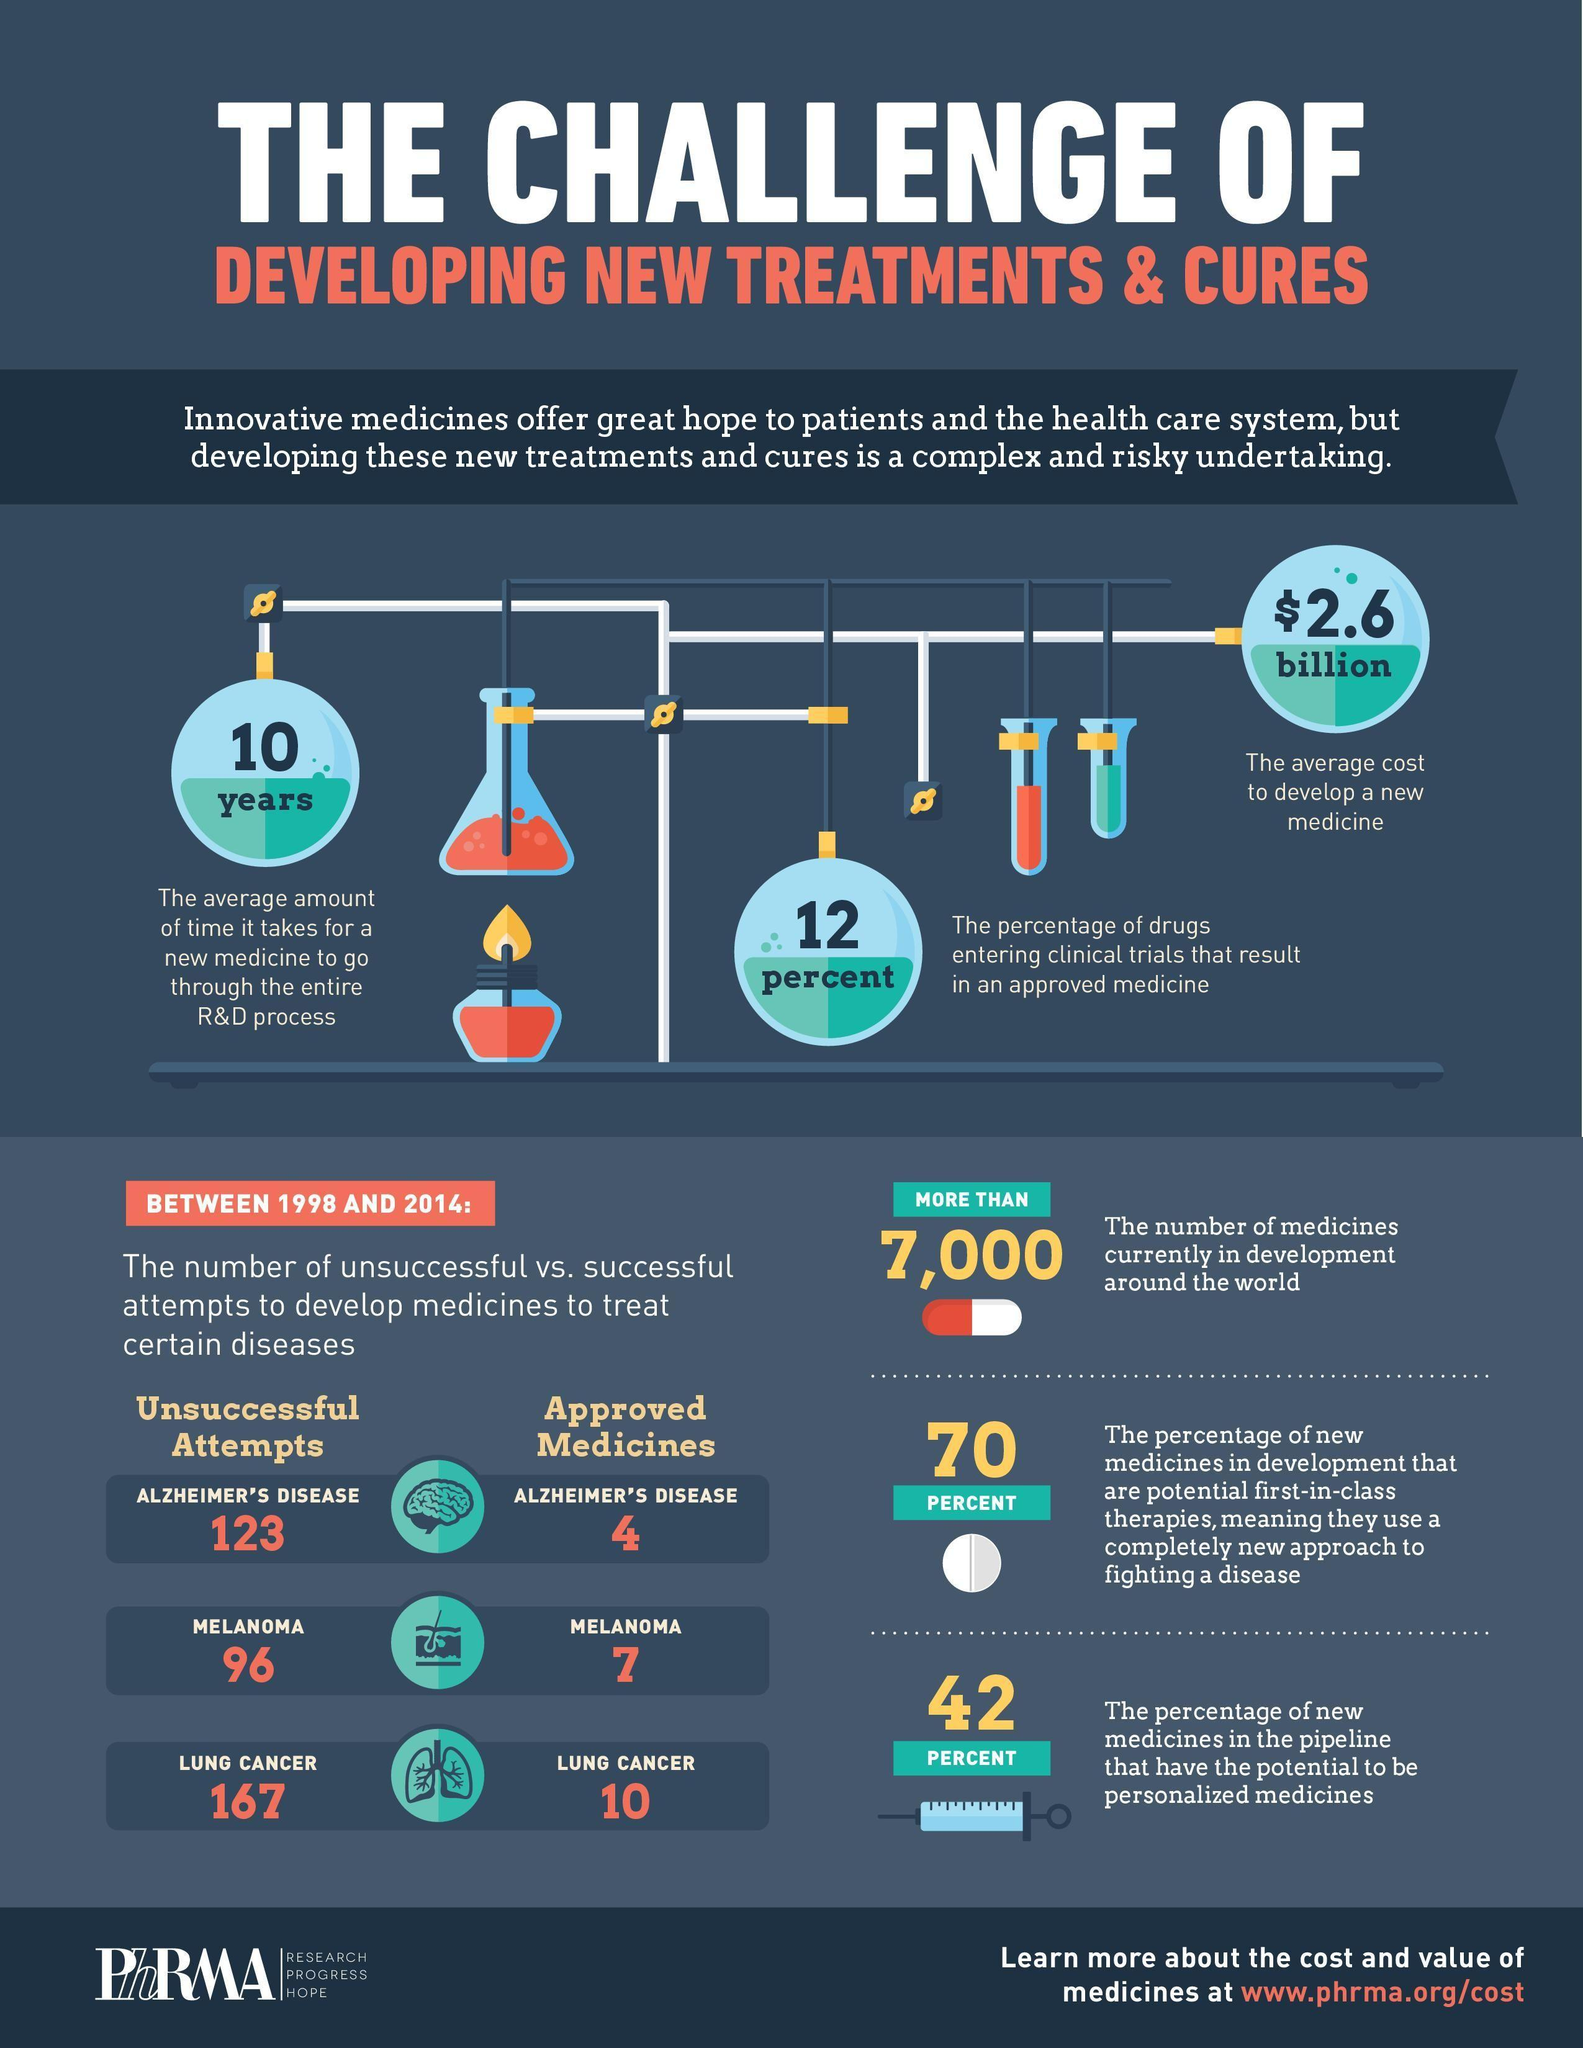How many unsuccessful attempts for Melanoma
Answer the question with a short phrase. 96 For which disease are there approved medicines alzheimer's disease, melanoma, lung cancer WHat is the average cost to develop a new medicine $2.6 billion How long does it take for a new medicine to go through the entire R&D process 10 years For which diseases has the attempts to develop medicines been unsuccessful alzheimer's disease, melanoma, lung cancer 